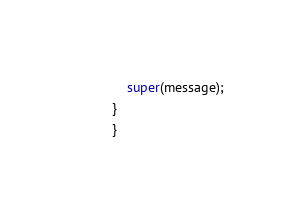Convert code to text. <code><loc_0><loc_0><loc_500><loc_500><_Java_>    super(message);
}
}
</code> 